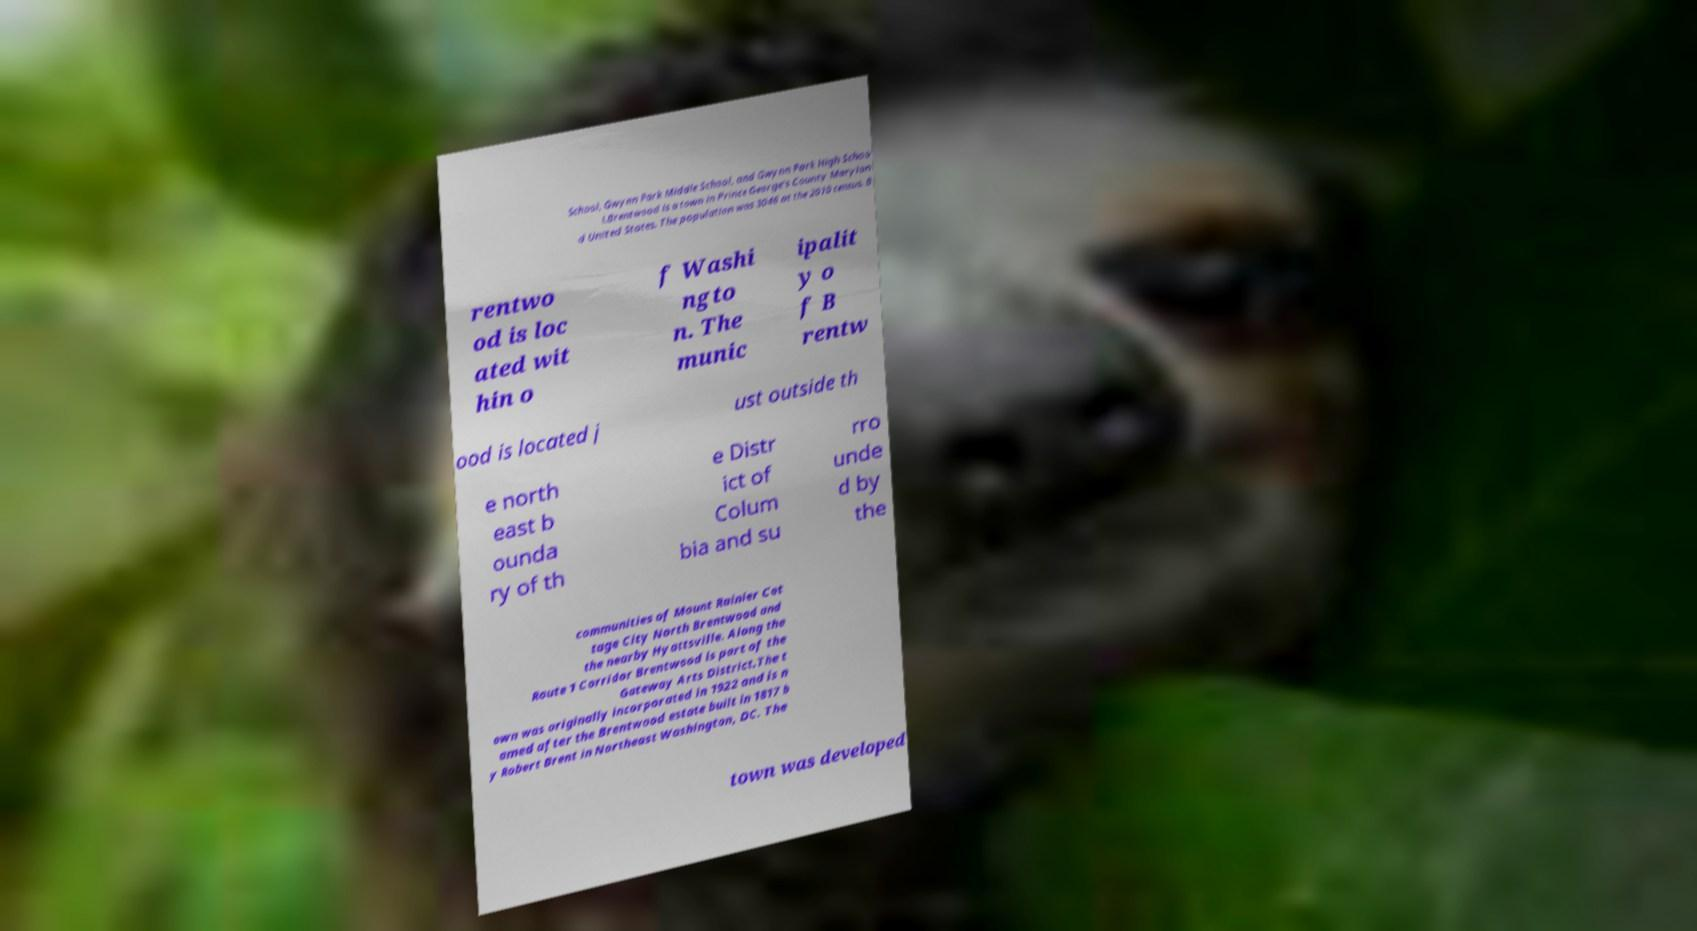Can you read and provide the text displayed in the image?This photo seems to have some interesting text. Can you extract and type it out for me? School, Gwynn Park Middle School, and Gwynn Park High Schoo l.Brentwood is a town in Prince George's County Marylan d United States. The population was 3046 at the 2010 census. B rentwo od is loc ated wit hin o f Washi ngto n. The munic ipalit y o f B rentw ood is located j ust outside th e north east b ounda ry of th e Distr ict of Colum bia and su rro unde d by the communities of Mount Rainier Cot tage City North Brentwood and the nearby Hyattsville. Along the Route 1 Corridor Brentwood is part of the Gateway Arts District.The t own was originally incorporated in 1922 and is n amed after the Brentwood estate built in 1817 b y Robert Brent in Northeast Washington, DC. The town was developed 